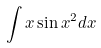Convert formula to latex. <formula><loc_0><loc_0><loc_500><loc_500>\int x \sin x ^ { 2 } d x</formula> 